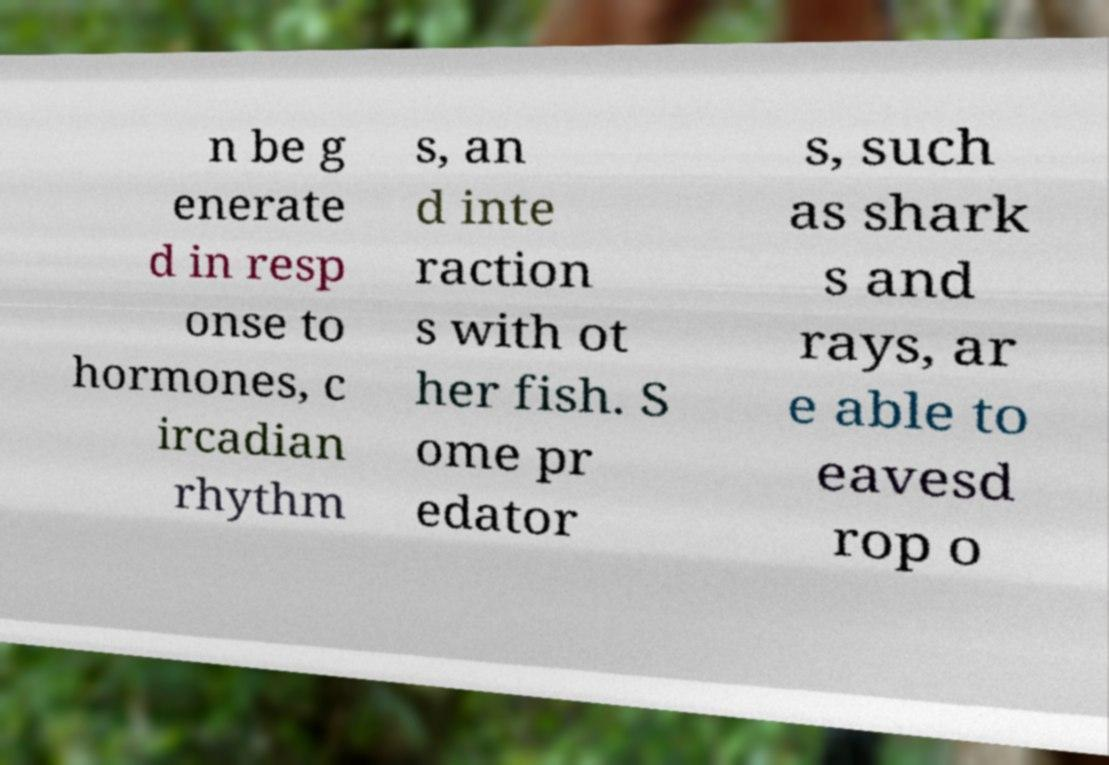Can you read and provide the text displayed in the image?This photo seems to have some interesting text. Can you extract and type it out for me? n be g enerate d in resp onse to hormones, c ircadian rhythm s, an d inte raction s with ot her fish. S ome pr edator s, such as shark s and rays, ar e able to eavesd rop o 